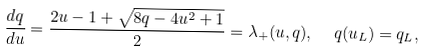Convert formula to latex. <formula><loc_0><loc_0><loc_500><loc_500>\frac { d q } { d u } = \frac { 2 u - 1 + \sqrt { 8 q - 4 u ^ { 2 } + 1 } } { 2 } = \lambda _ { + } ( u , q ) , \ \ q ( u _ { L } ) = q _ { L } ,</formula> 